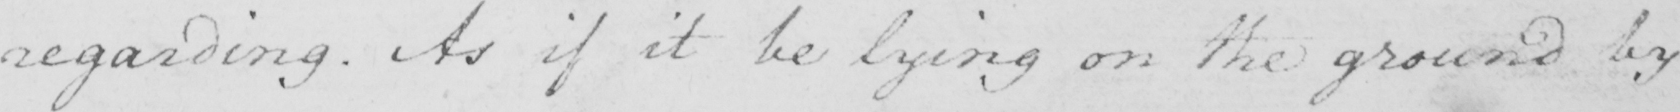What is written in this line of handwriting? regarding . As if it be lying on the ground by 